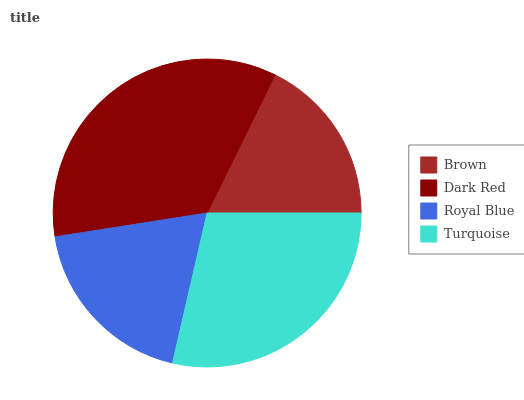Is Brown the minimum?
Answer yes or no. Yes. Is Dark Red the maximum?
Answer yes or no. Yes. Is Royal Blue the minimum?
Answer yes or no. No. Is Royal Blue the maximum?
Answer yes or no. No. Is Dark Red greater than Royal Blue?
Answer yes or no. Yes. Is Royal Blue less than Dark Red?
Answer yes or no. Yes. Is Royal Blue greater than Dark Red?
Answer yes or no. No. Is Dark Red less than Royal Blue?
Answer yes or no. No. Is Turquoise the high median?
Answer yes or no. Yes. Is Royal Blue the low median?
Answer yes or no. Yes. Is Royal Blue the high median?
Answer yes or no. No. Is Brown the low median?
Answer yes or no. No. 